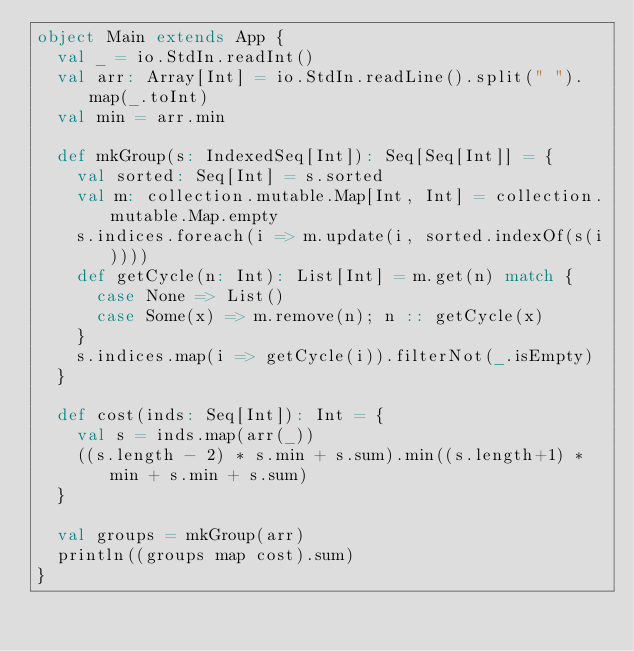Convert code to text. <code><loc_0><loc_0><loc_500><loc_500><_Scala_>object Main extends App {
  val _ = io.StdIn.readInt()
  val arr: Array[Int] = io.StdIn.readLine().split(" ").map(_.toInt)
  val min = arr.min

  def mkGroup(s: IndexedSeq[Int]): Seq[Seq[Int]] = {
    val sorted: Seq[Int] = s.sorted
    val m: collection.mutable.Map[Int, Int] = collection.mutable.Map.empty
    s.indices.foreach(i => m.update(i, sorted.indexOf(s(i))))
    def getCycle(n: Int): List[Int] = m.get(n) match {
      case None => List()
      case Some(x) => m.remove(n); n :: getCycle(x)
    }
    s.indices.map(i => getCycle(i)).filterNot(_.isEmpty)
  }

  def cost(inds: Seq[Int]): Int = {
    val s = inds.map(arr(_))
    ((s.length - 2) * s.min + s.sum).min((s.length+1) * min + s.min + s.sum)
  }

  val groups = mkGroup(arr)
  println((groups map cost).sum)
}</code> 